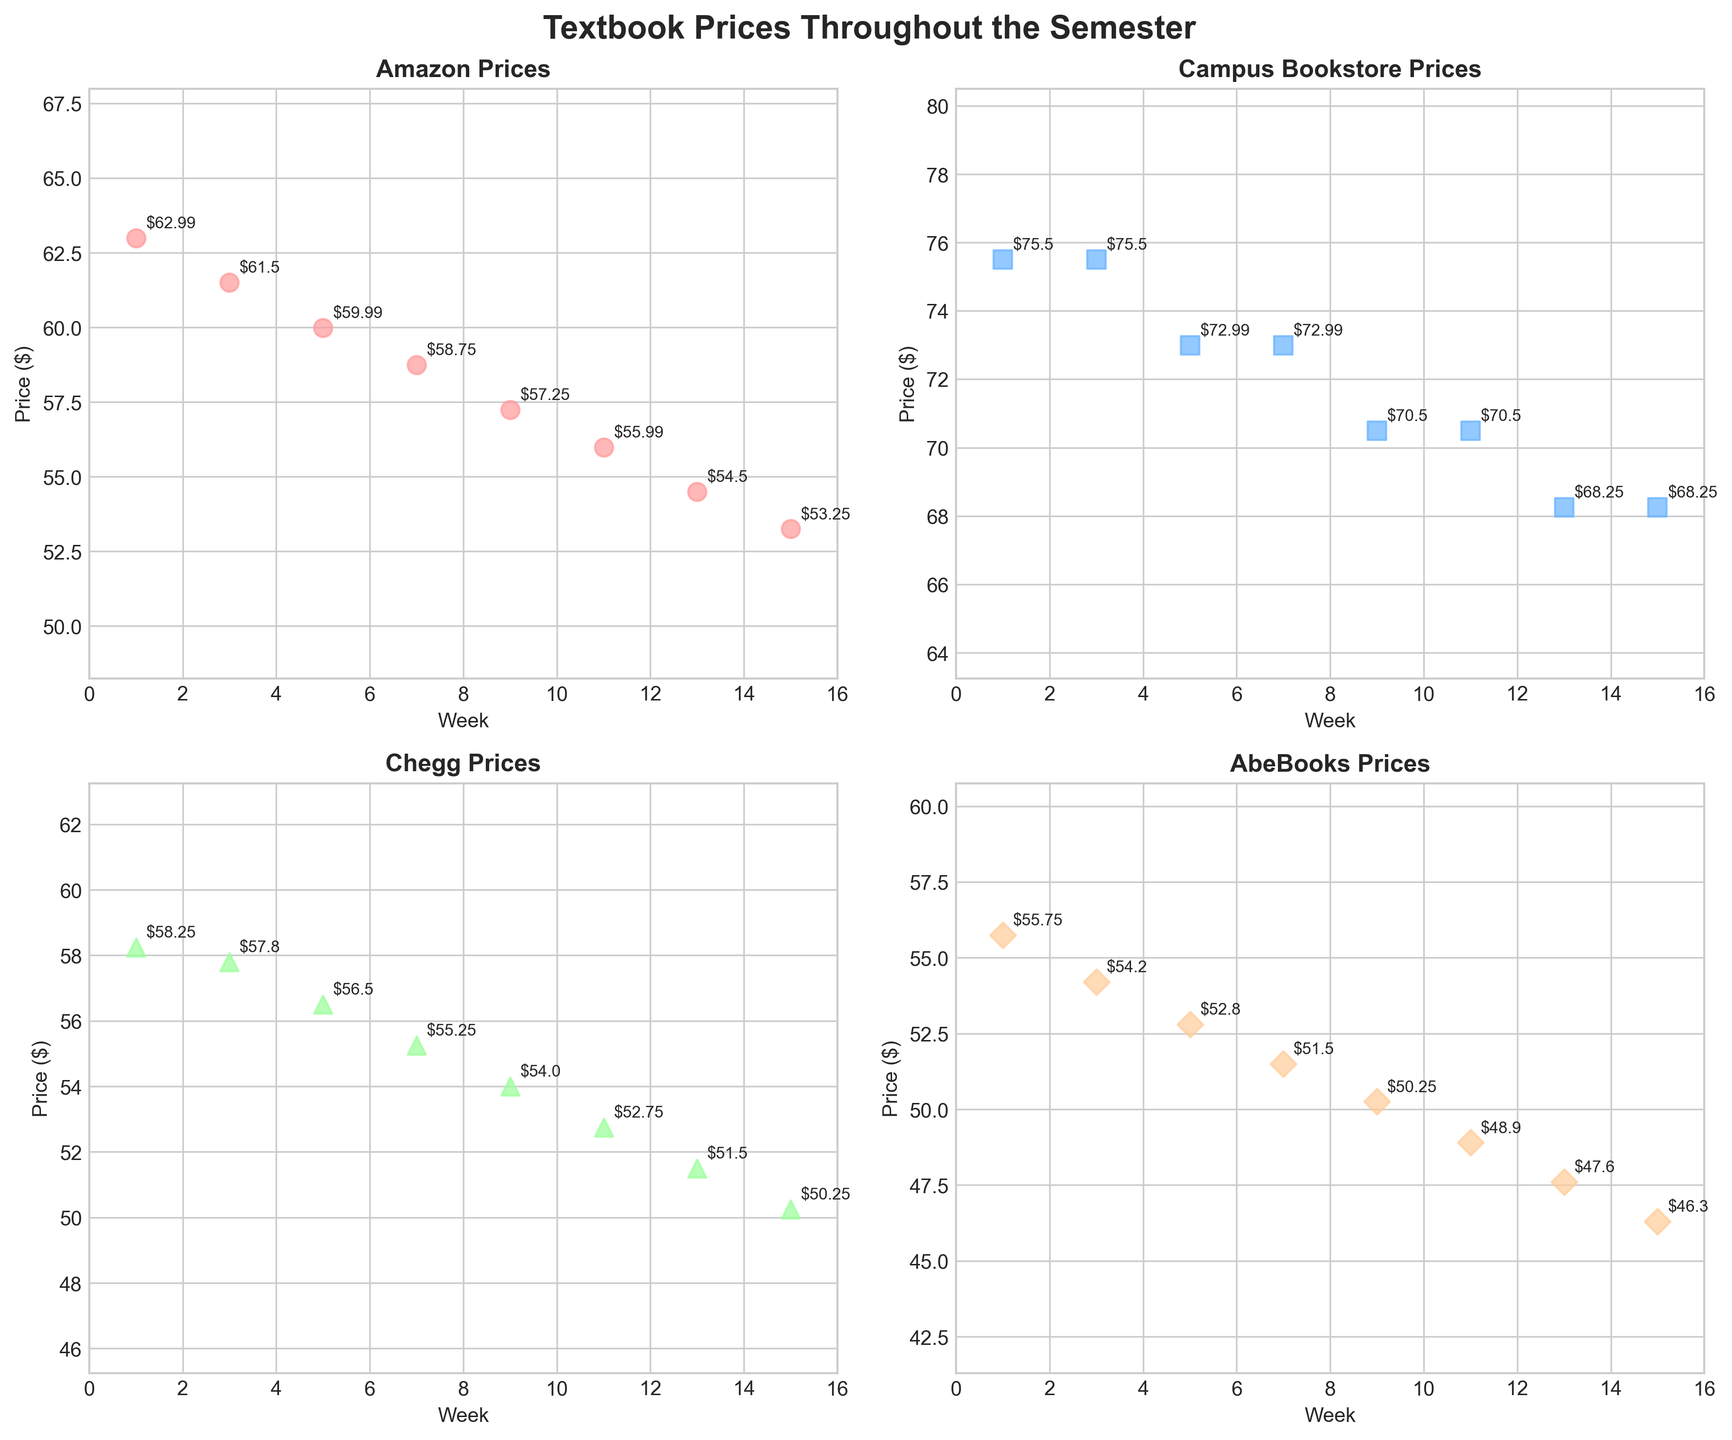What is the title of the figure? The title is usually shown at the top of the figure. In this case, the title is "Textbook Prices Throughout the Semester."
Answer: Textbook Prices Throughout the Semester What is the price of textbooks on Amazon in week 1? Locate the Amazon subplot and find the price point for week 1. The annotation should show the price clearly. The price of textbooks on Amazon in week 1 is $62.99.
Answer: $62.99 Which source has the lowest textbook price in week 15? Look at all four subplots and compare the prices in week 15. You will see that AbeBooks offers the lowest price in week 15, which is $46.30.
Answer: AbeBooks How do the prices at the Campus Bookstore change over the weeks? Examine the Campus Bookstore subplot. The prices remain constant at $75.50 for the first 2 data points, then drop to $72.99 for the next 2 data points and continue to decrease steadily.
Answer: Decreasing What is the average price of Chegg textbooks over the entire semester? Sum all the prices for Chegg ($58.25 + $57.80 + $56.50 + $55.25 + $54.00 + $52.75 + $51.50 + $50.25) and divide by the number of weeks (8). The average price is (436.30 / 8) = 54.54.
Answer: $54.54 Which week shows the largest difference in textbook prices between Amazon and the Campus Bookstore? Calculate the difference for each week. The largest difference is in week 1: $75.50 (Campus Bookstore) - $62.99 (Amazon) = $12.51.
Answer: Week 1 How does the trend in pricing compare between Amazon and Chegg? Check the subplots for Amazon and Chegg. Both sources show a decreasing trend, but the rate of decrease is different. Chegg's prices decrease more sharply compared to Amazon.
Answer: Chegg decreases more sharply than Amazon Which source has the most consistent pricing, with the least fluctuation, over the semester? Review the range of prices for each source. Campus Bookstore shows the most consistent pricing since their prices drop only twice and remain relatively stable.
Answer: Campus Bookstore What is the price differential between the highest and lowest sources in week 9? Check the prices for all sources in week 9. The highest is Campus Bookstore ($70.50) and the lowest is AbeBooks ($50.25). So, the differential is $70.50 - $50.25 = $20.25.
Answer: $20.25 